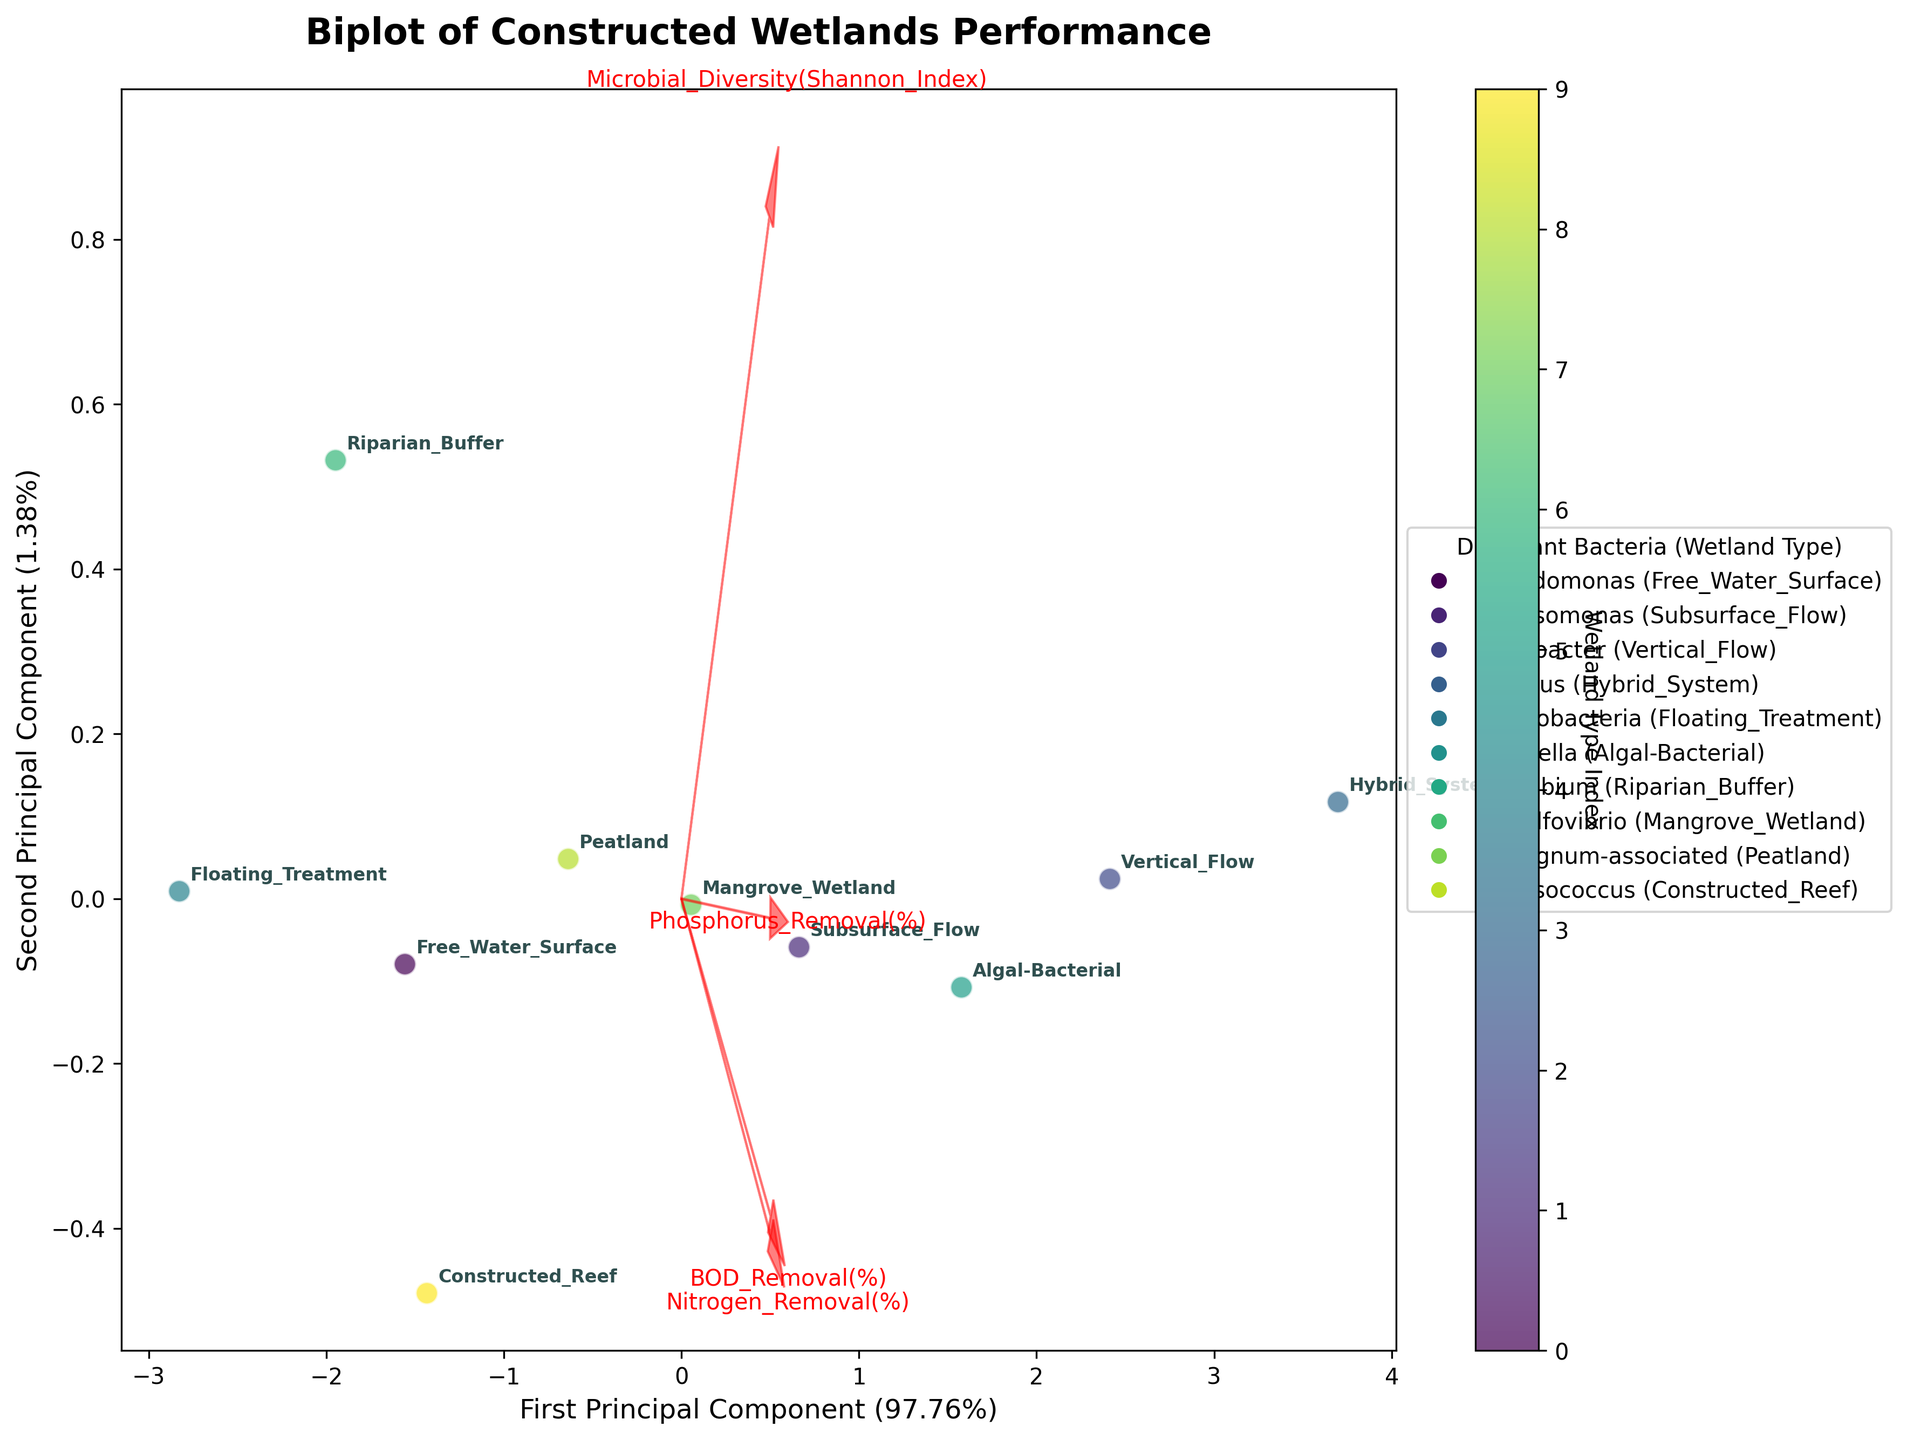What's the title of the plot? The title is typically at the top of the plot and usually larger in font size. It describes the overall purpose of the figure. In this case, it reads "Biplot of Constructed Wetlands Performance".
Answer: Biplot of Constructed Wetlands Performance How many wetland types are represented in the biplot? By counting the number of unique labels on the scatter plot, we see there are 10 different wetland types. Each label represents a distinct wetland type.
Answer: 10 Which wetland type has the highest nitrogen removal efficiency based on the plot? According to the data used to create the plot, the Vertical Flow wetland has the highest nitrogen removal efficiency. The labels in the scatter plot help identify the position of Vertical Flow in the biplot.
Answer: Vertical Flow How does the microbial diversity of the Hybrid System compare to that of the Free Water Surface wetland? By examining their positions relative to the Microbial Diversity vector arrow, we can see that the Hybrid System is further in the positive direction, indicating higher microbial diversity compared to the Free Water Surface wetland.
Answer: Higher What does the first principal component represent more generally in this biplot? The first principal component explains the largest variation among the data points. In the biplot, most of the feature vectors (like nitrogen removal and BOD removal) point strongly in the direction of the first principal component, indicating it captures major aspects of nutrient removal and microbial diversity.
Answer: Major aspects of nutrient removal and microbial diversity Which constructed wetland type is associated with the highest microbial diversity (Shannon Index)? Based on the position in the biplot relative to the Microbial Diversity vector, the Hybrid System wetland has the highest Shannon Index value.
Answer: Hybrid System Is there a wetland type that has both high phosphorus removal and high BOD removal? By inspecting the data points and their associated labels in the biplot, the Hybrid System is the wetland type that shows high values in both phosphorus removal and BOD removal, as inferred from their directions.
Answer: Yes (Hybrid System) What can you infer about the relationship between BOD removal and Nitrogen removal efficiencies in constructed wetlands? The vectors for BOD removal and Nitrogen removal point in similar directions in the biplot, indicating a positive correlation. Wetlands tending to have high BOD removal often also have high nitrogen removal.
Answer: Positive correlation Which wetland type is represented by the bacterium Chlorella, and how does it perform in terms of microbial diversity? The Algal-Bacterial wetland, associated with Chlorella, can be identified in the scatter plot. It positions relatively high in the direction of the Microbial Diversity vector, indicating good performance in microbial diversity.
Answer: Algal-Bacterial (Good performance in microbial diversity) What percentage of the variation in the data is explained by the first two principal components combined? By looking at the labels on the x-axis and y-axis of the biplot, we sum the individual variances explained: 63.2% + 24.5%, which totals to 87.7%.
Answer: 87.7% 